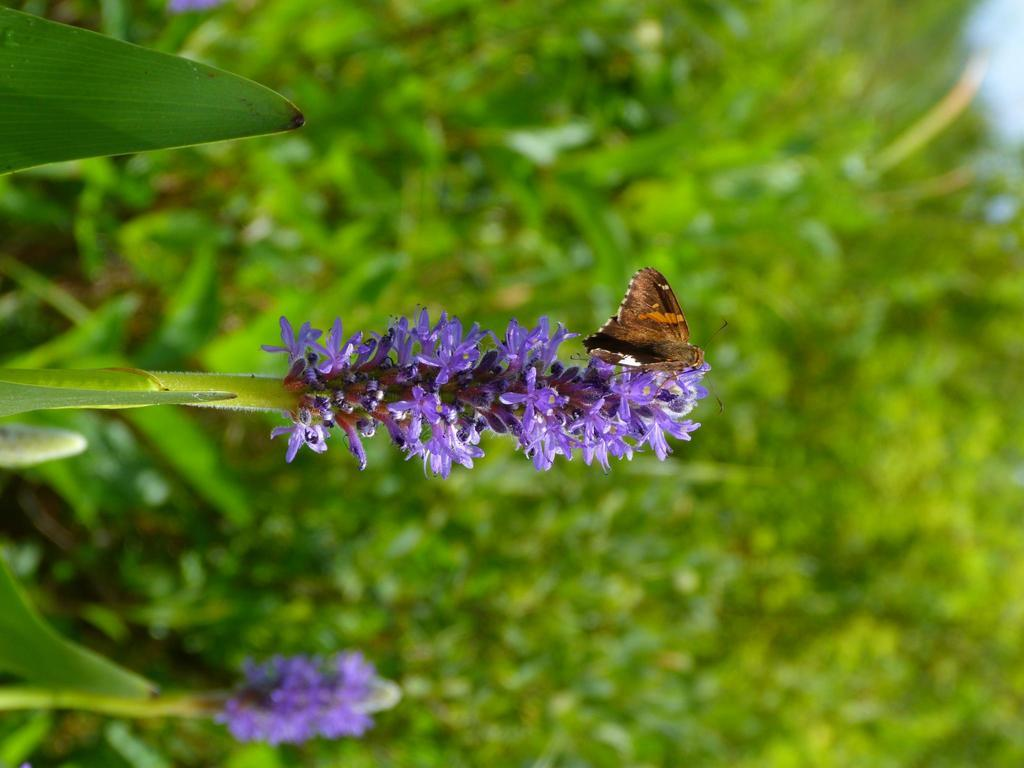What type of flower is present in the image? There is a purple color flower in the image. What part of the flower is visible? The flower has a stem. What other living creature can be seen in the image? There is a butterfly in the image. Where is the butterfly located in relation to the flower? The butterfly is on the flower. What type of plant material is present in the image? The image contains leaves. How would you describe the background of the image? The background of the image is blurred. What type of tramp can be seen in the image? There is no tramp present in the image; it features a flower with a butterfly on it, leaves, and a blurred background. Can you tell me how many rocks are visible in the image? There are no rocks visible in the image. 